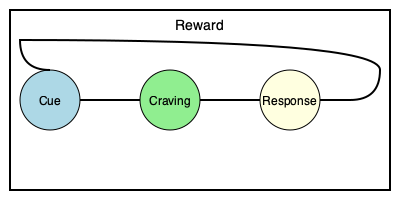In the habit loop shown above, which component directly follows the "Craving" stage and represents the actual behavior or action taken? To answer this question, let's break down the habit loop shown in the diagram:

1. The habit loop is a cyclical process consisting of four main components: Cue, Craving, Response, and Reward.

2. The diagram shows these components in a specific order:
   a) Cue (light blue circle)
   b) Craving (light green circle)
   c) Response (light yellow circle)
   d) Reward (represented by the arrow looping back)

3. The question asks about the component that directly follows the "Craving" stage.

4. Looking at the diagram, we can see that the "Response" stage (light yellow circle) comes immediately after the "Craving" stage.

5. The "Response" represents the actual behavior or action taken in response to the craving. It's the visible part of the habit that we can observe.

6. After the "Response," the loop continues to the "Reward" stage, which reinforces the habit and loops back to the beginning.

Therefore, the component that directly follows the "Craving" stage and represents the actual behavior or action taken is the "Response."
Answer: Response 